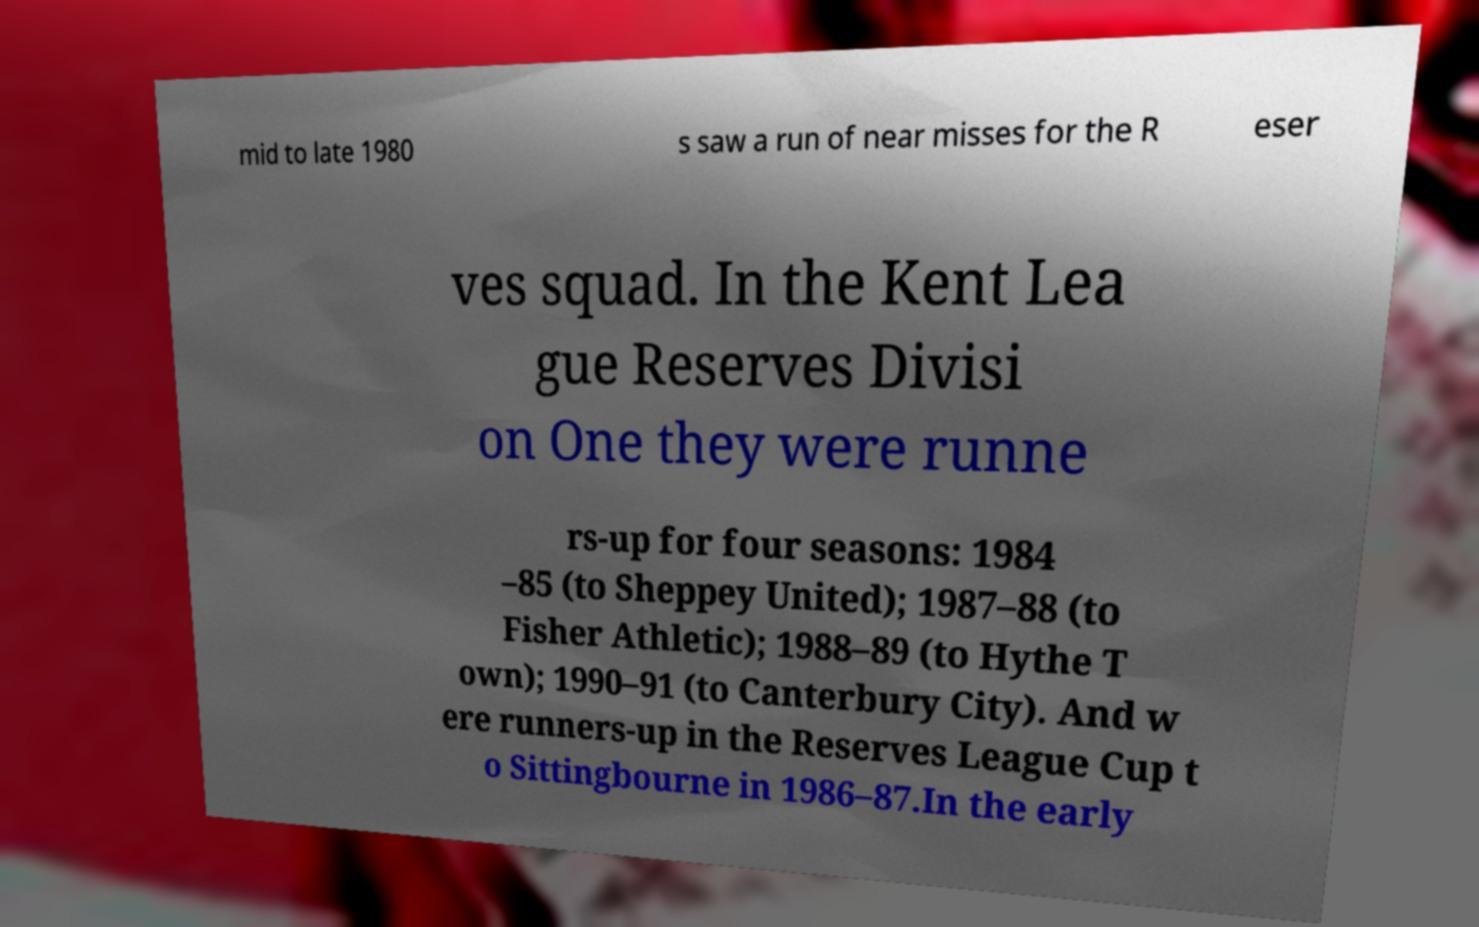What messages or text are displayed in this image? I need them in a readable, typed format. mid to late 1980 s saw a run of near misses for the R eser ves squad. In the Kent Lea gue Reserves Divisi on One they were runne rs-up for four seasons: 1984 –85 (to Sheppey United); 1987–88 (to Fisher Athletic); 1988–89 (to Hythe T own); 1990–91 (to Canterbury City). And w ere runners-up in the Reserves League Cup t o Sittingbourne in 1986–87.In the early 